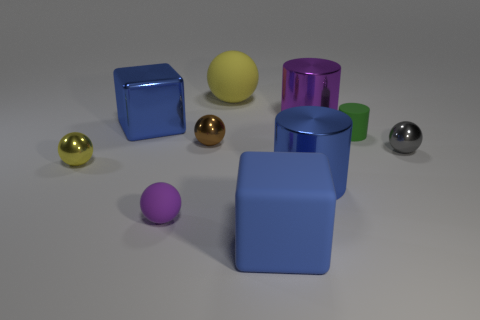Subtract all large cylinders. How many cylinders are left? 1 Subtract all gray balls. How many balls are left? 4 Subtract 2 balls. How many balls are left? 3 Subtract all brown balls. Subtract all yellow cylinders. How many balls are left? 4 Subtract 0 purple blocks. How many objects are left? 10 Subtract all blocks. How many objects are left? 8 Subtract all tiny brown spheres. Subtract all big blue blocks. How many objects are left? 7 Add 7 brown spheres. How many brown spheres are left? 8 Add 6 gray shiny cubes. How many gray shiny cubes exist? 6 